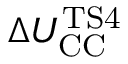Convert formula to latex. <formula><loc_0><loc_0><loc_500><loc_500>\Delta U _ { C C } ^ { T S 4 }</formula> 